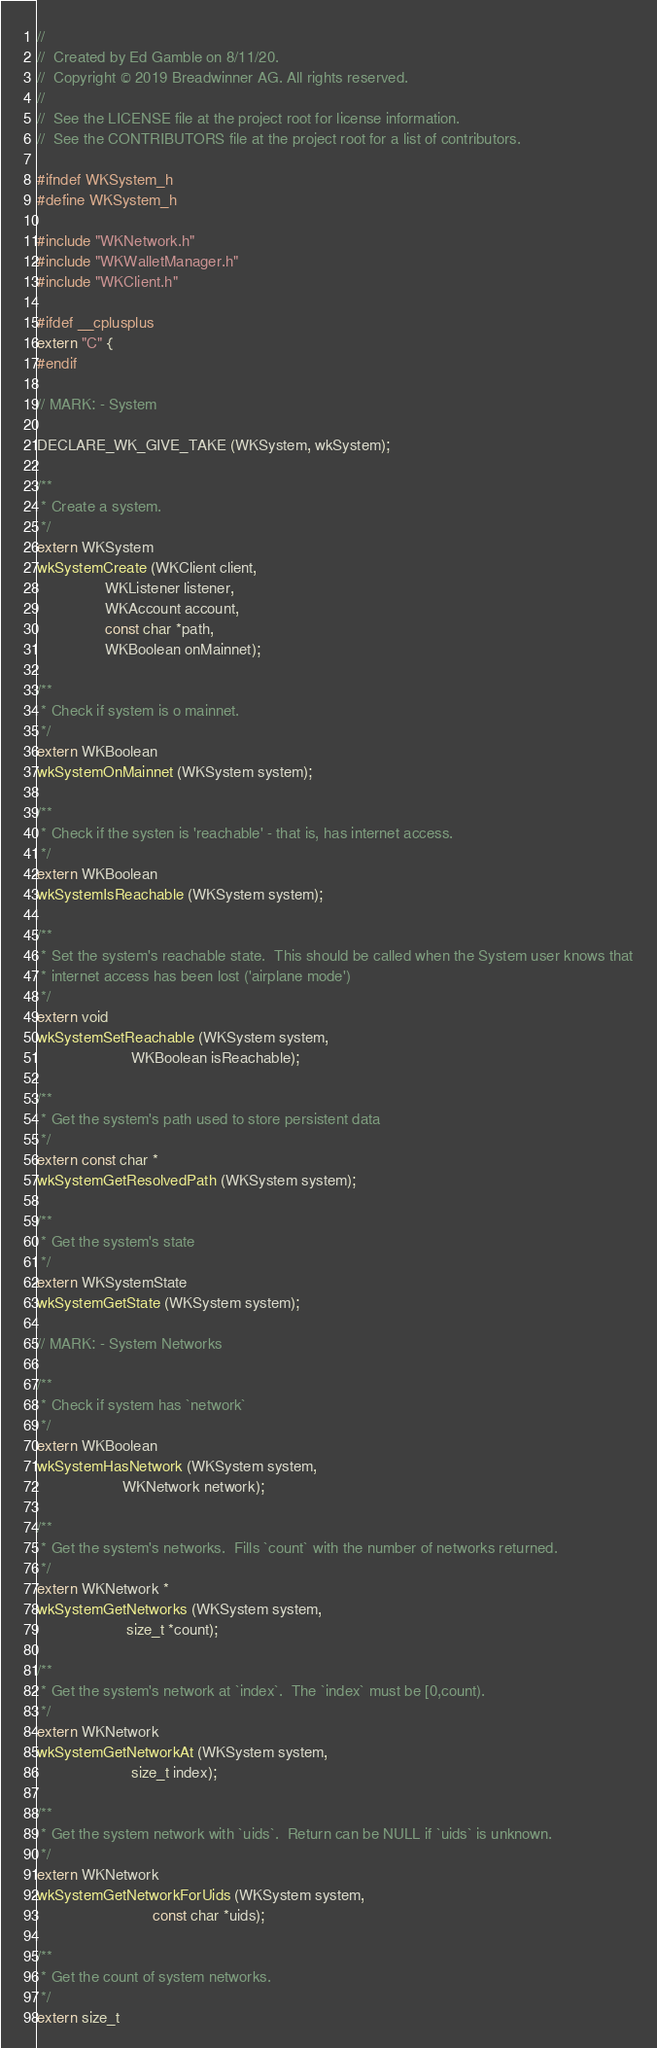Convert code to text. <code><loc_0><loc_0><loc_500><loc_500><_C_>//
//  Created by Ed Gamble on 8/11/20.
//  Copyright © 2019 Breadwinner AG. All rights reserved.
//
//  See the LICENSE file at the project root for license information.
//  See the CONTRIBUTORS file at the project root for a list of contributors.

#ifndef WKSystem_h
#define WKSystem_h

#include "WKNetwork.h"
#include "WKWalletManager.h"
#include "WKClient.h"

#ifdef __cplusplus
extern "C" {
#endif

// MARK: - System

DECLARE_WK_GIVE_TAKE (WKSystem, wkSystem);

/**
 * Create a system.
 */
extern WKSystem
wkSystemCreate (WKClient client,
                WKListener listener,
                WKAccount account,
                const char *path,
                WKBoolean onMainnet);

/**
 * Check if system is o mainnet.
 */
extern WKBoolean
wkSystemOnMainnet (WKSystem system);

/**
 * Check if the systen is 'reachable' - that is, has internet access.
 */
extern WKBoolean
wkSystemIsReachable (WKSystem system);

/**
 * Set the system's reachable state.  This should be called when the System user knows that
 * internet access has been lost ('airplane mode')
 */
extern void
wkSystemSetReachable (WKSystem system,
                      WKBoolean isReachable);

/**
 * Get the system's path used to store persistent data
 */
extern const char *
wkSystemGetResolvedPath (WKSystem system);

/**
 * Get the system's state
 */
extern WKSystemState
wkSystemGetState (WKSystem system);

// MARK: - System Networks

/**
 * Check if system has `network`
 */
extern WKBoolean
wkSystemHasNetwork (WKSystem system,
                    WKNetwork network);

/**
 * Get the system's networks.  Fills `count` with the number of networks returned.
 */
extern WKNetwork *
wkSystemGetNetworks (WKSystem system,
                     size_t *count);

/**
 * Get the system's network at `index`.  The `index` must be [0,count).
 */
extern WKNetwork
wkSystemGetNetworkAt (WKSystem system,
                      size_t index);

/**
 * Get the system network with `uids`.  Return can be NULL if `uids` is unknown.
 */
extern WKNetwork
wkSystemGetNetworkForUids (WKSystem system,
                           const char *uids);

/**
 * Get the count of system networks.
 */
extern size_t</code> 